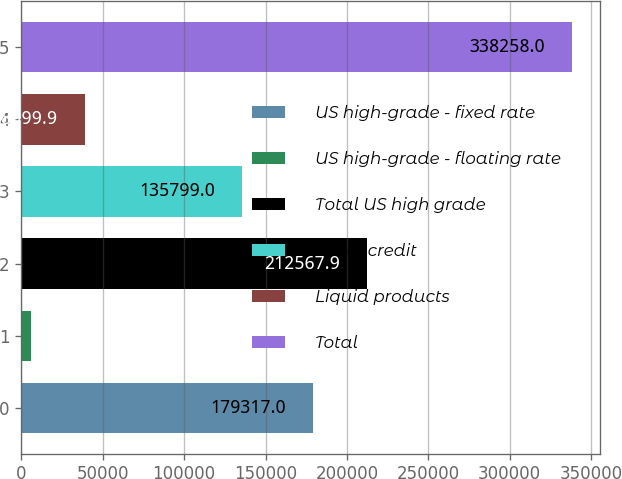Convert chart. <chart><loc_0><loc_0><loc_500><loc_500><bar_chart><fcel>US high-grade - fixed rate<fcel>US high-grade - floating rate<fcel>Total US high grade<fcel>Other credit<fcel>Liquid products<fcel>Total<nl><fcel>179317<fcel>5749<fcel>212568<fcel>135799<fcel>38999.9<fcel>338258<nl></chart> 